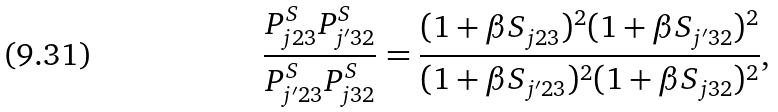Convert formula to latex. <formula><loc_0><loc_0><loc_500><loc_500>\frac { P ^ { S } _ { j 2 3 } P ^ { S } _ { j ^ { \prime } 3 2 } } { P ^ { S } _ { j ^ { \prime } 2 3 } P ^ { S } _ { j 3 2 } } = \frac { ( 1 + \beta S _ { j 2 3 } ) ^ { 2 } ( 1 + \beta S _ { j ^ { \prime } 3 2 } ) ^ { 2 } } { ( 1 + \beta S _ { j ^ { \prime } 2 3 } ) ^ { 2 } ( 1 + \beta S _ { j 3 2 } ) ^ { 2 } } ,</formula> 